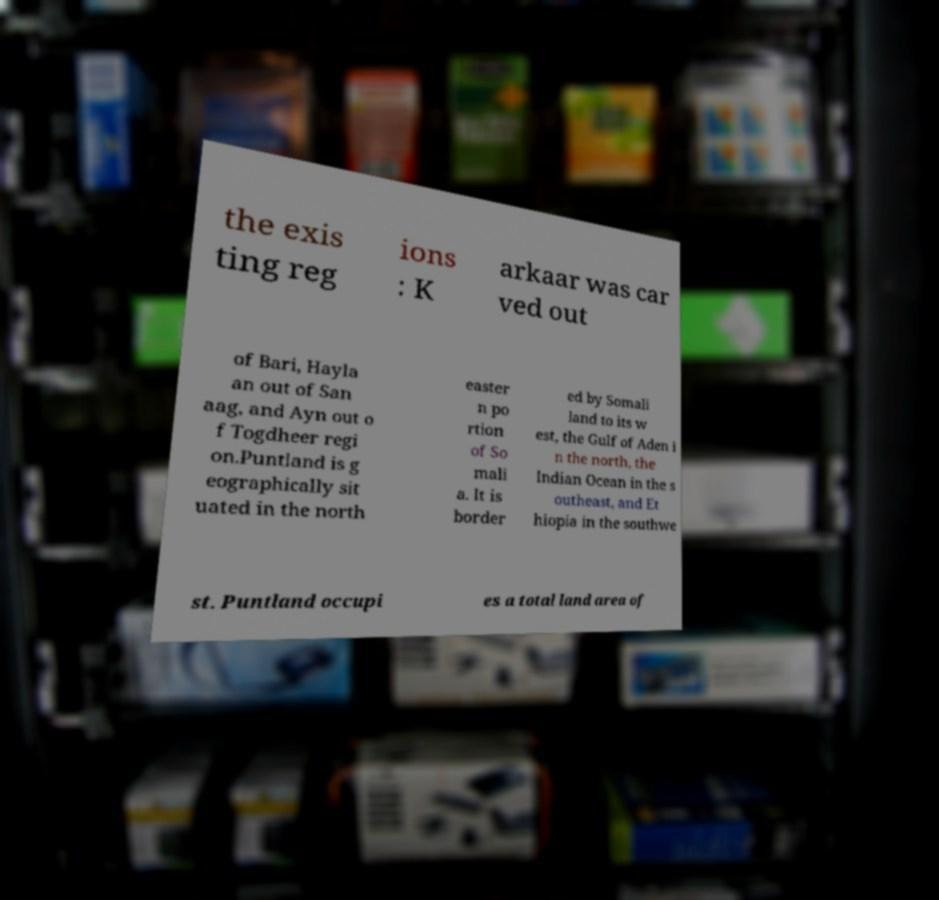Could you assist in decoding the text presented in this image and type it out clearly? the exis ting reg ions : K arkaar was car ved out of Bari, Hayla an out of San aag, and Ayn out o f Togdheer regi on.Puntland is g eographically sit uated in the north easter n po rtion of So mali a. It is border ed by Somali land to its w est, the Gulf of Aden i n the north, the Indian Ocean in the s outheast, and Et hiopia in the southwe st. Puntland occupi es a total land area of 